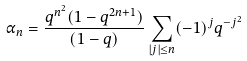Convert formula to latex. <formula><loc_0><loc_0><loc_500><loc_500>\alpha _ { n } = \frac { q ^ { n ^ { 2 } } ( 1 - q ^ { 2 n + 1 } ) } { ( 1 - q ) } \sum _ { | j | \leq n } ( - 1 ) ^ { j } q ^ { - j ^ { 2 } }</formula> 